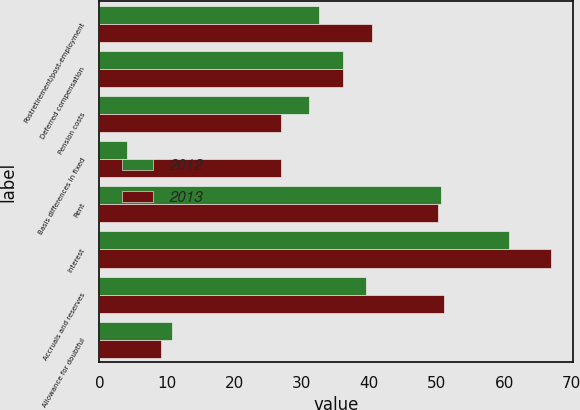Convert chart. <chart><loc_0><loc_0><loc_500><loc_500><stacked_bar_chart><ecel><fcel>Postretirement/post-employment<fcel>Deferred compensation<fcel>Pension costs<fcel>Basis differences in fixed<fcel>Rent<fcel>Interest<fcel>Accruals and reserves<fcel>Allowance for doubtful<nl><fcel>2012<fcel>32.5<fcel>36.05<fcel>31.1<fcel>4.1<fcel>50.7<fcel>60.7<fcel>39.6<fcel>10.8<nl><fcel>2013<fcel>40.4<fcel>36.05<fcel>27<fcel>26.9<fcel>50.2<fcel>66.9<fcel>51.1<fcel>9.2<nl></chart> 